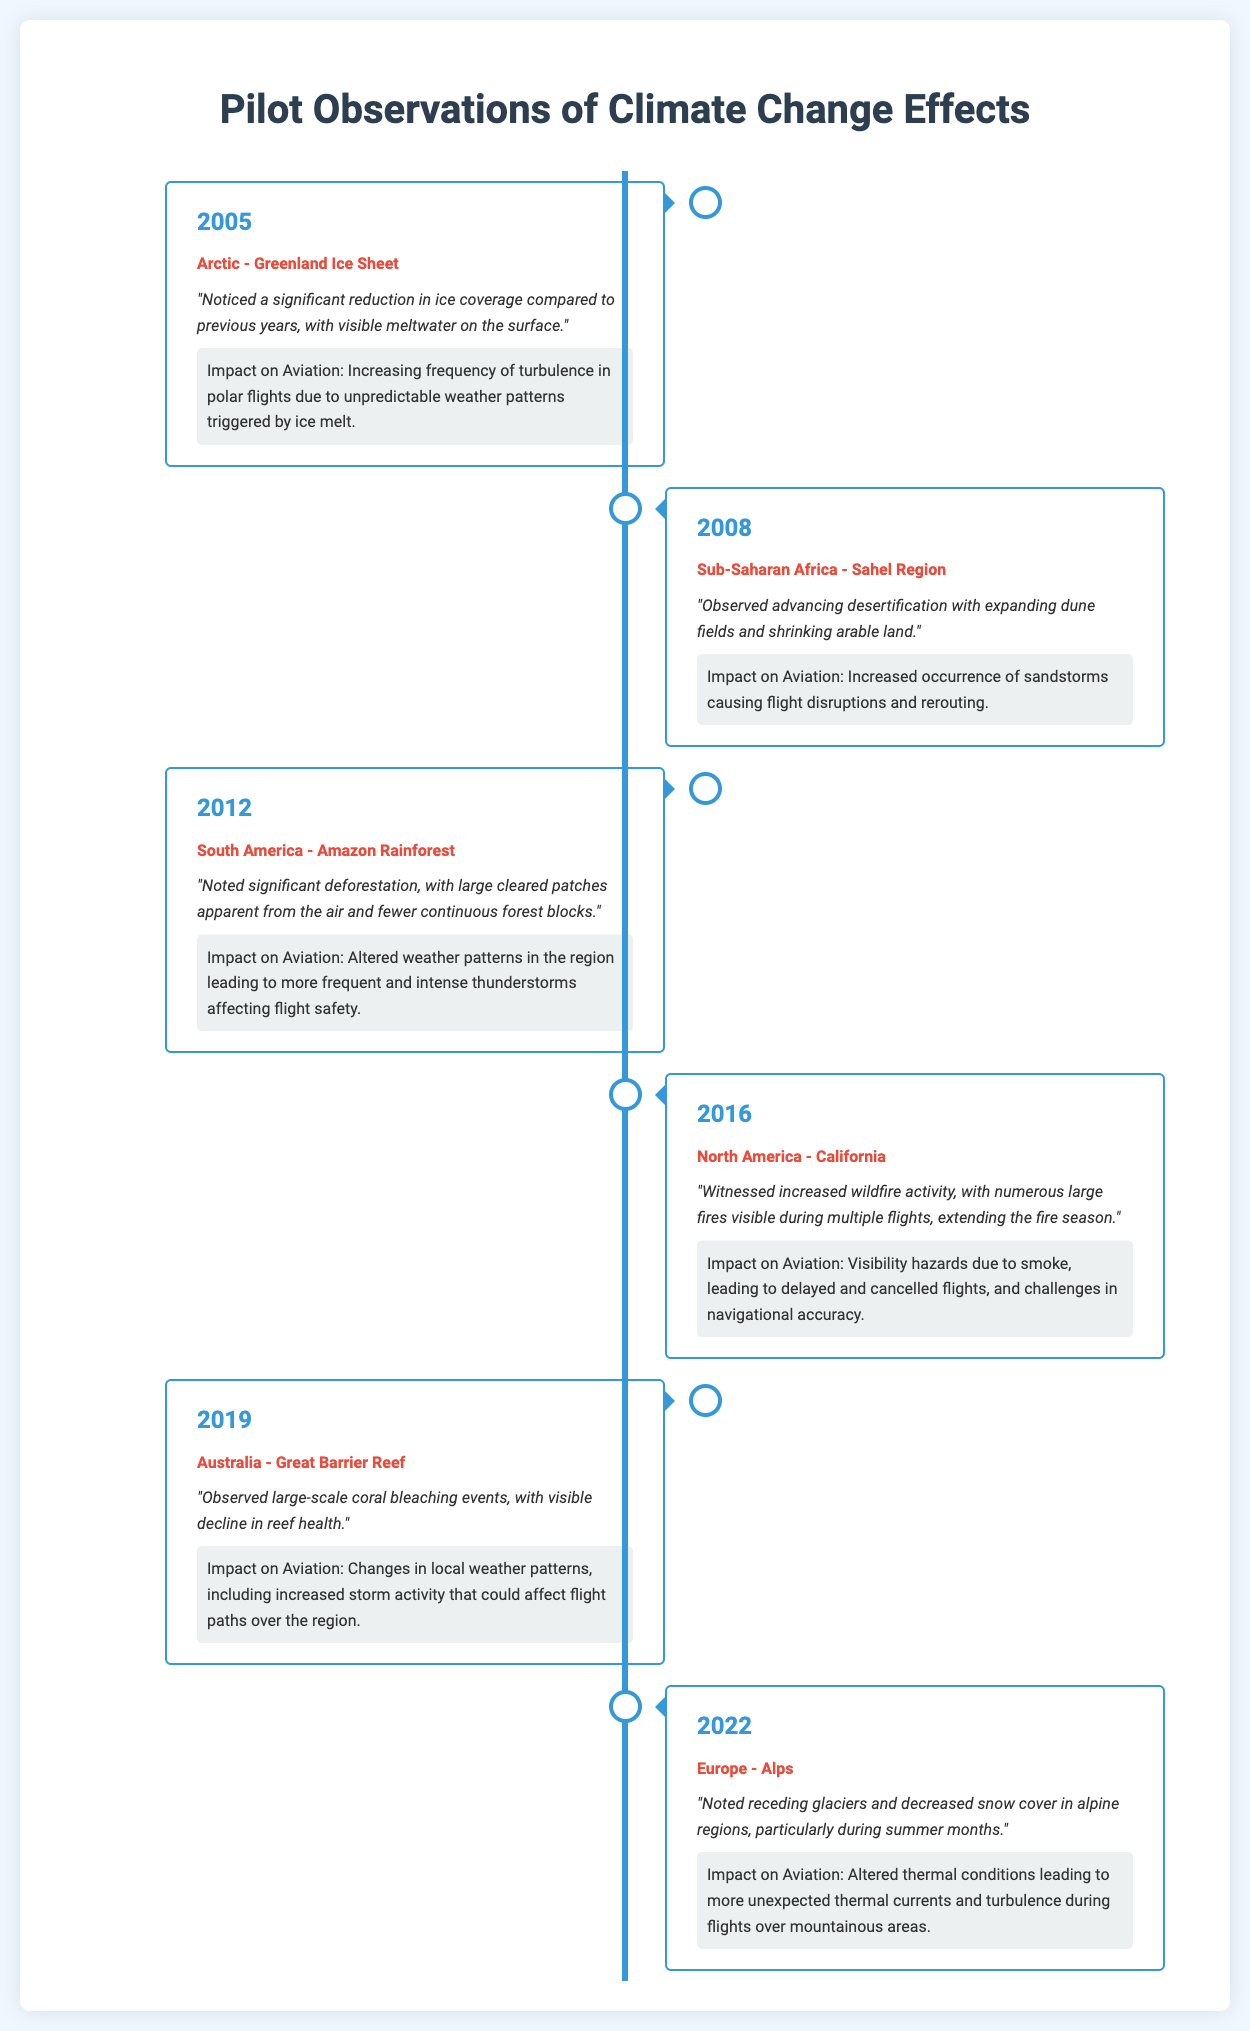What year was significant ice melt observed in Greenland? The document states that significant ice melt was observed in Greenland in the year 2005.
Answer: 2005 What environmental change was noted in the Amazon Rainforest? The observation noted significant deforestation in the Amazon Rainforest with large cleared patches.
Answer: Deforestation Which region experienced increased desertification in 2008? The timeline specifies the Sahel Region in Sub-Saharan Africa for increased desertification in 2008.
Answer: Sahel Region What was a major impact on aviation observed in California in 2016? The document mentions that increased wildfire activity in California led to visibility hazards due to smoke.
Answer: Visibility hazards In what year did pilots observe coral bleaching in the Great Barrier Reef? According to the timeline, coral bleaching in the Great Barrier Reef was observed in 2019.
Answer: 2019 What was the primary observation regarding the Alps in 2022? The primary observation noted receding glaciers and decreased snow cover in alpine regions during summer months.
Answer: Receding glaciers How many different regions are listed in the observations? There are a total of six different regions listed throughout the timeline from the observations.
Answer: Six What specific weather pattern change was noted as a result of deforestation in the Amazon? The observation indicates altered weather patterns leading to more frequent and intense thunderstorms affecting flight safety.
Answer: Intense thunderstorms What impact did increased sandstorms have on aviation in 2008? The document notes that the increased occurrence of sandstorms caused flight disruptions and rerouting.
Answer: Flight disruptions 